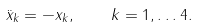<formula> <loc_0><loc_0><loc_500><loc_500>\ddot { x } _ { k } = - x _ { k } , \quad k = 1 , \dots 4 .</formula> 